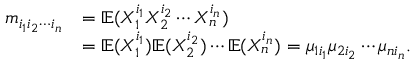<formula> <loc_0><loc_0><loc_500><loc_500>\begin{array} { r l } { m _ { i _ { 1 } i _ { 2 } \cdots i _ { n } } } & { = \mathbb { E } ( X _ { 1 } ^ { i _ { 1 } } X _ { 2 } ^ { i _ { 2 } } \cdots X _ { n } ^ { i _ { n } } ) } \\ & { = \mathbb { E } ( X _ { 1 } ^ { i _ { 1 } } ) \mathbb { E } ( X _ { 2 } ^ { i _ { 2 } } ) \cdots \mathbb { E } ( X _ { n } ^ { i _ { n } } ) = \mu _ { 1 i _ { 1 } } \mu _ { 2 i _ { 2 } } \cdots \mu _ { n i _ { n } } . } \end{array}</formula> 